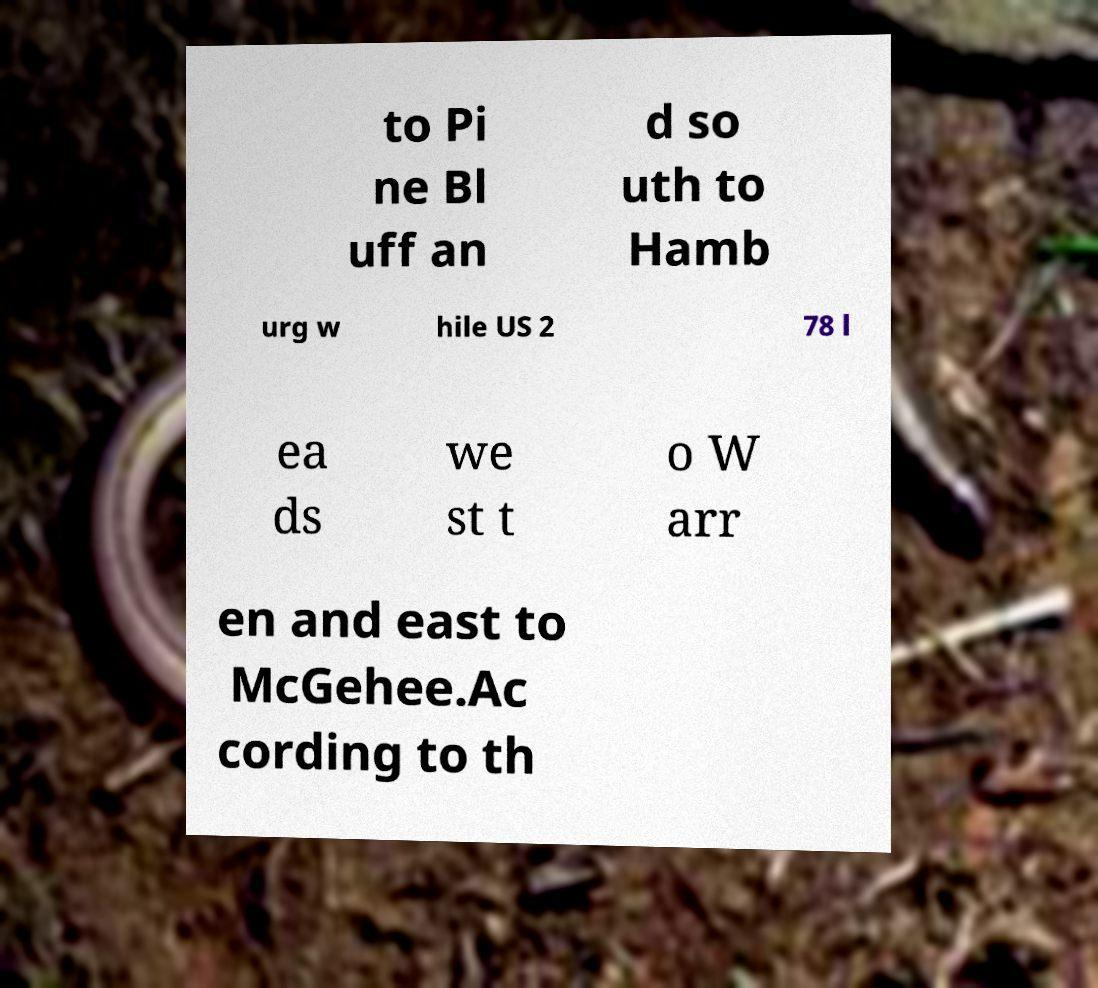Could you assist in decoding the text presented in this image and type it out clearly? to Pi ne Bl uff an d so uth to Hamb urg w hile US 2 78 l ea ds we st t o W arr en and east to McGehee.Ac cording to th 